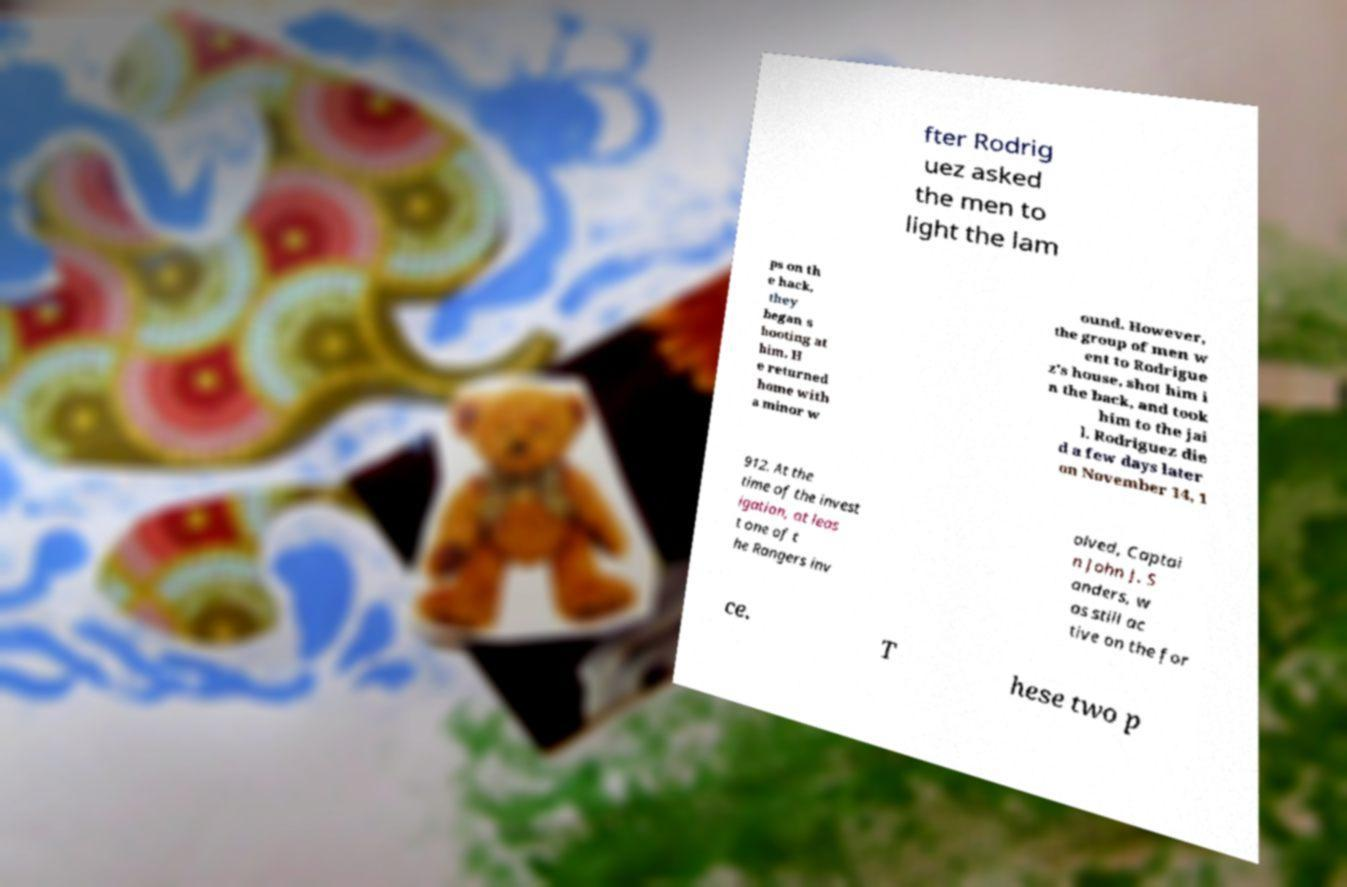For documentation purposes, I need the text within this image transcribed. Could you provide that? fter Rodrig uez asked the men to light the lam ps on th e hack, they began s hooting at him. H e returned home with a minor w ound. However, the group of men w ent to Rodrigue z's house, shot him i n the back, and took him to the jai l. Rodriguez die d a few days later on November 14, 1 912. At the time of the invest igation, at leas t one of t he Rangers inv olved, Captai n John J. S anders, w as still ac tive on the for ce. T hese two p 